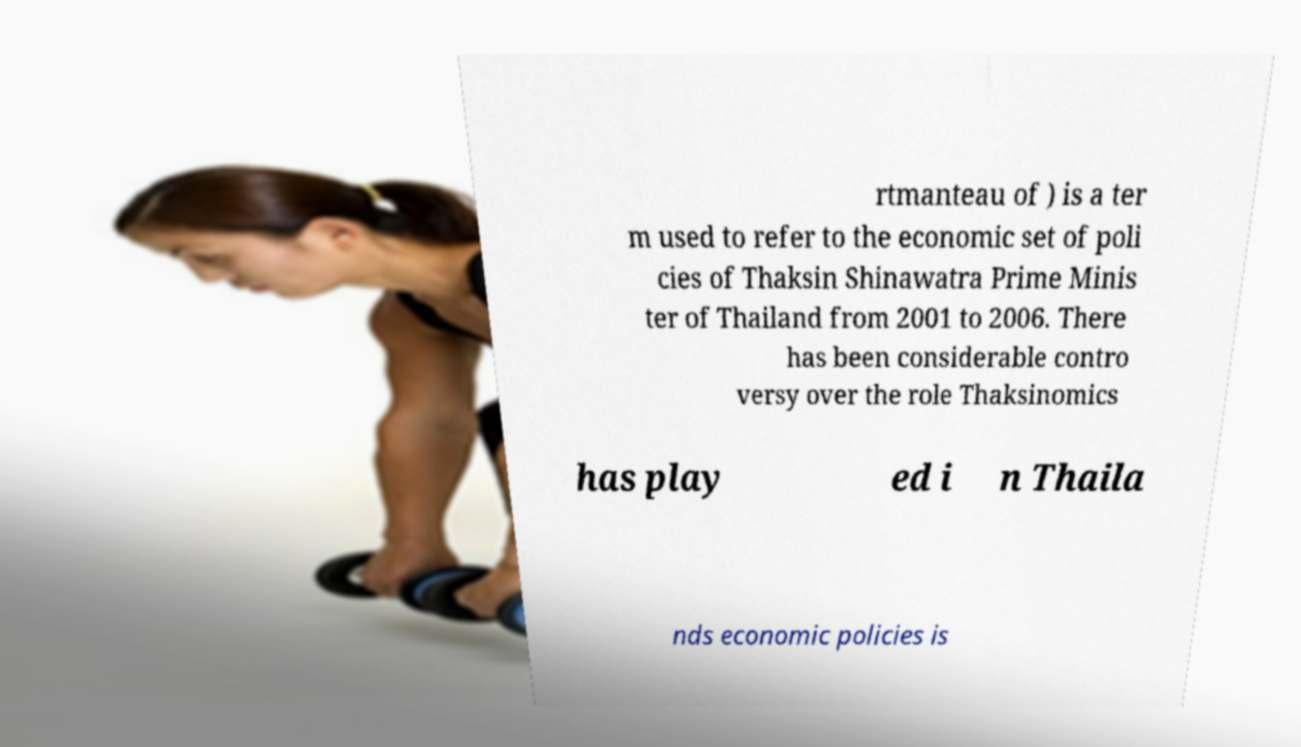For documentation purposes, I need the text within this image transcribed. Could you provide that? rtmanteau of ) is a ter m used to refer to the economic set of poli cies of Thaksin Shinawatra Prime Minis ter of Thailand from 2001 to 2006. There has been considerable contro versy over the role Thaksinomics has play ed i n Thaila nds economic policies is 